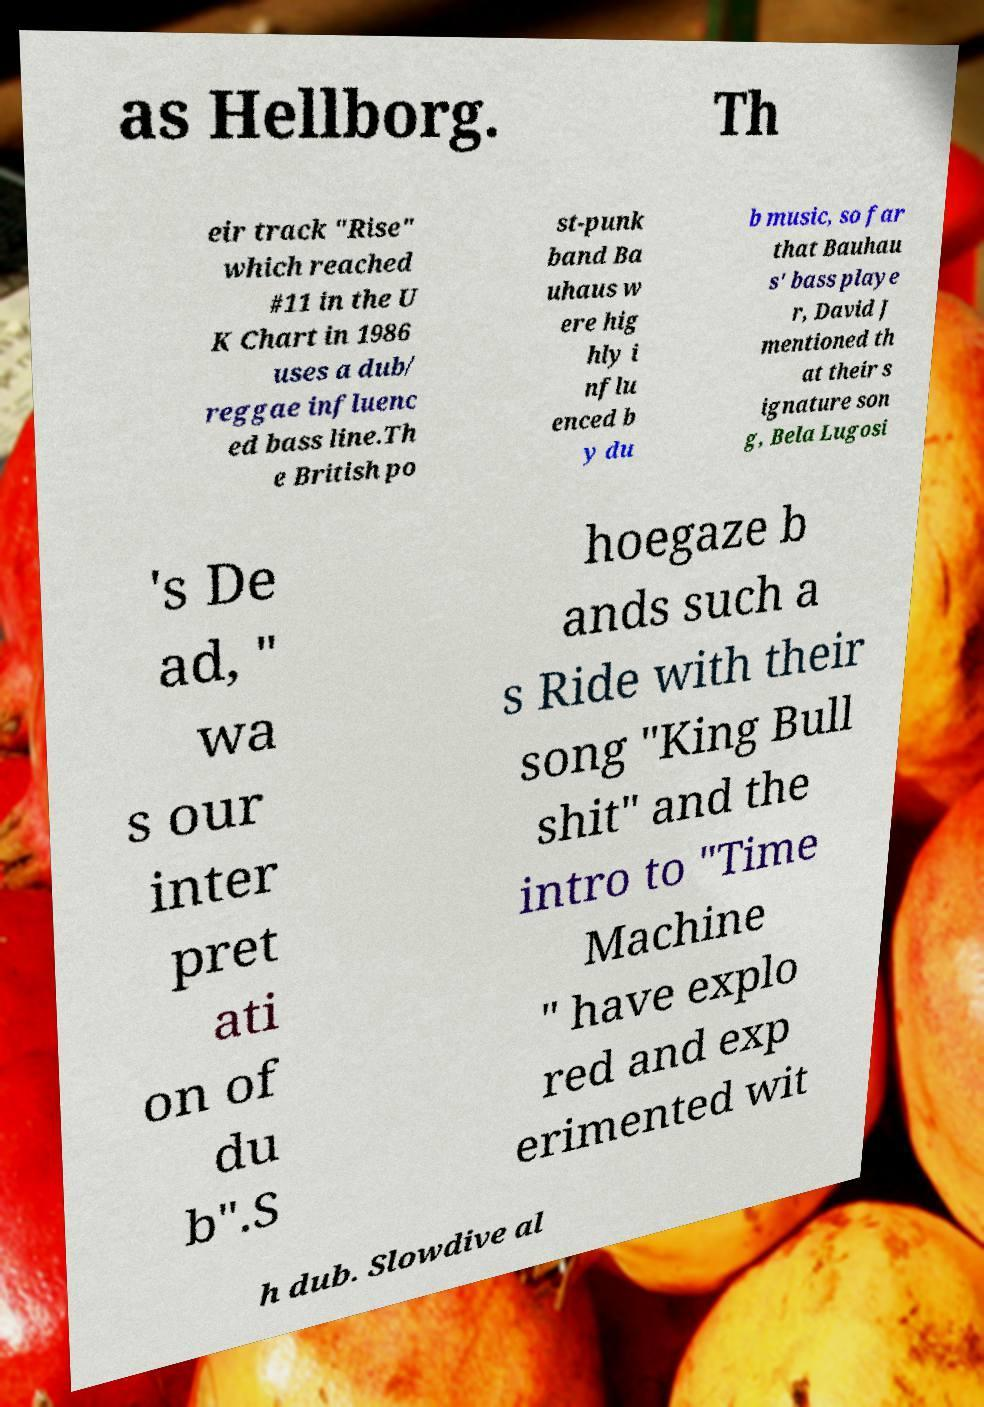Could you extract and type out the text from this image? as Hellborg. Th eir track "Rise" which reached #11 in the U K Chart in 1986 uses a dub/ reggae influenc ed bass line.Th e British po st-punk band Ba uhaus w ere hig hly i nflu enced b y du b music, so far that Bauhau s' bass playe r, David J mentioned th at their s ignature son g, Bela Lugosi 's De ad, " wa s our inter pret ati on of du b".S hoegaze b ands such a s Ride with their song "King Bull shit" and the intro to "Time Machine " have explo red and exp erimented wit h dub. Slowdive al 